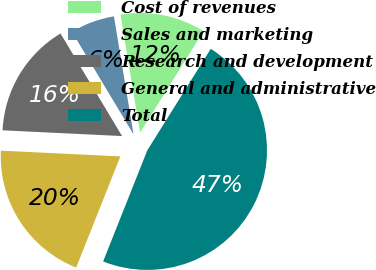Convert chart. <chart><loc_0><loc_0><loc_500><loc_500><pie_chart><fcel>Cost of revenues<fcel>Sales and marketing<fcel>Research and development<fcel>General and administrative<fcel>Total<nl><fcel>11.51%<fcel>5.98%<fcel>15.63%<fcel>19.74%<fcel>47.13%<nl></chart> 